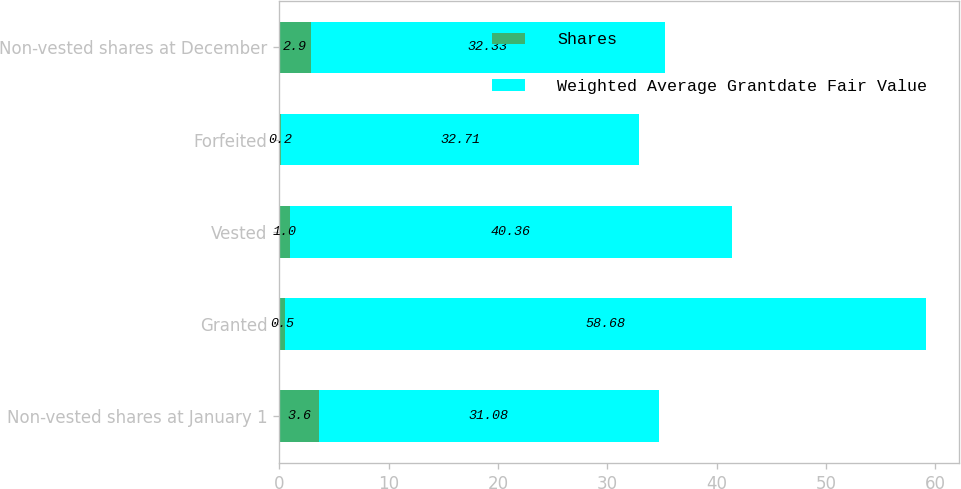<chart> <loc_0><loc_0><loc_500><loc_500><stacked_bar_chart><ecel><fcel>Non-vested shares at January 1<fcel>Granted<fcel>Vested<fcel>Forfeited<fcel>Non-vested shares at December<nl><fcel>Shares<fcel>3.6<fcel>0.5<fcel>1<fcel>0.2<fcel>2.9<nl><fcel>Weighted Average Grantdate Fair Value<fcel>31.08<fcel>58.68<fcel>40.36<fcel>32.71<fcel>32.33<nl></chart> 